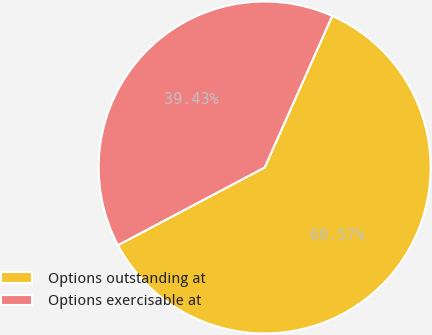Convert chart. <chart><loc_0><loc_0><loc_500><loc_500><pie_chart><fcel>Options outstanding at<fcel>Options exercisable at<nl><fcel>60.57%<fcel>39.43%<nl></chart> 